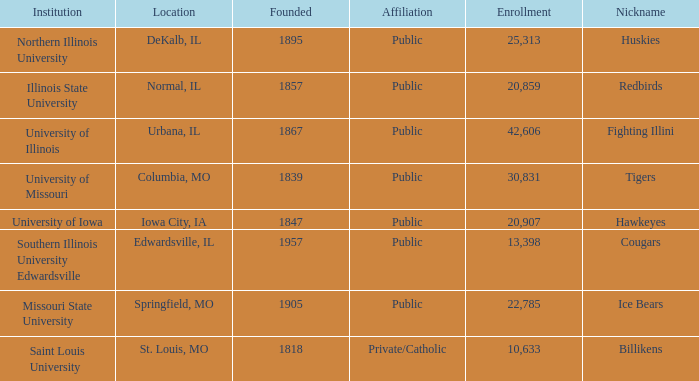What is Southern Illinois University Edwardsville's affiliation? Public. 